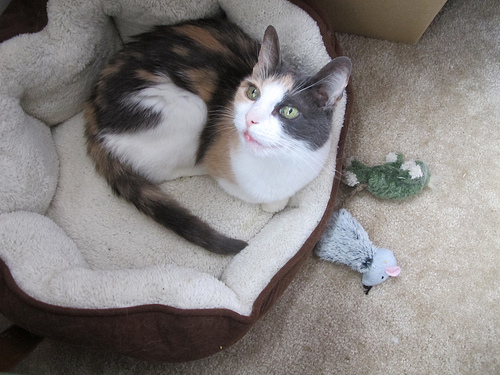<image>
Is there a cat in the floor? No. The cat is not contained within the floor. These objects have a different spatial relationship. Is there a mouse behind the cat? No. The mouse is not behind the cat. From this viewpoint, the mouse appears to be positioned elsewhere in the scene. 